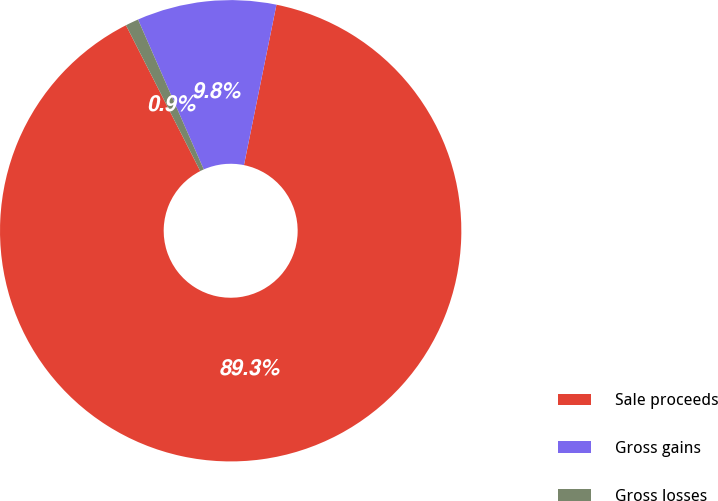<chart> <loc_0><loc_0><loc_500><loc_500><pie_chart><fcel>Sale proceeds<fcel>Gross gains<fcel>Gross losses<nl><fcel>89.32%<fcel>9.76%<fcel>0.92%<nl></chart> 